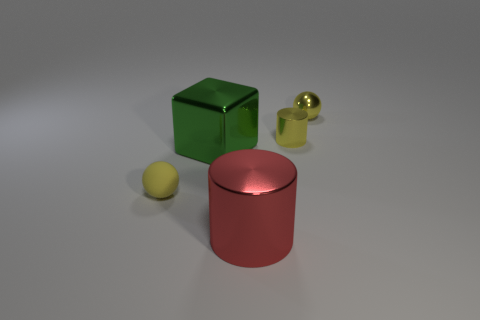What is the color of the cylinder that is the same size as the rubber thing?
Keep it short and to the point. Yellow. There is a ball to the left of the yellow thing that is behind the yellow metallic cylinder; what is its size?
Your response must be concise. Small. Does the cube have the same color as the metallic cylinder in front of the large green object?
Provide a short and direct response. No. Is the number of large metallic cubes behind the metal sphere less than the number of cyan matte things?
Provide a short and direct response. No. How many other objects are there of the same size as the shiny cube?
Make the answer very short. 1. Does the large object that is in front of the small yellow rubber object have the same shape as the big green metal object?
Make the answer very short. No. Are there more tiny objects that are behind the small yellow cylinder than big cylinders?
Your answer should be compact. No. There is a thing that is in front of the small cylinder and on the right side of the large green thing; what is its material?
Keep it short and to the point. Metal. Is there any other thing that is the same shape as the small matte object?
Keep it short and to the point. Yes. How many objects are left of the big red thing and behind the tiny yellow matte sphere?
Give a very brief answer. 1. 